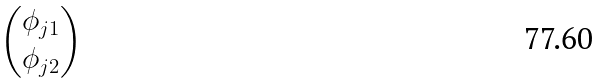<formula> <loc_0><loc_0><loc_500><loc_500>\begin{pmatrix} \phi _ { j 1 } \\ \phi _ { j 2 } \end{pmatrix}</formula> 